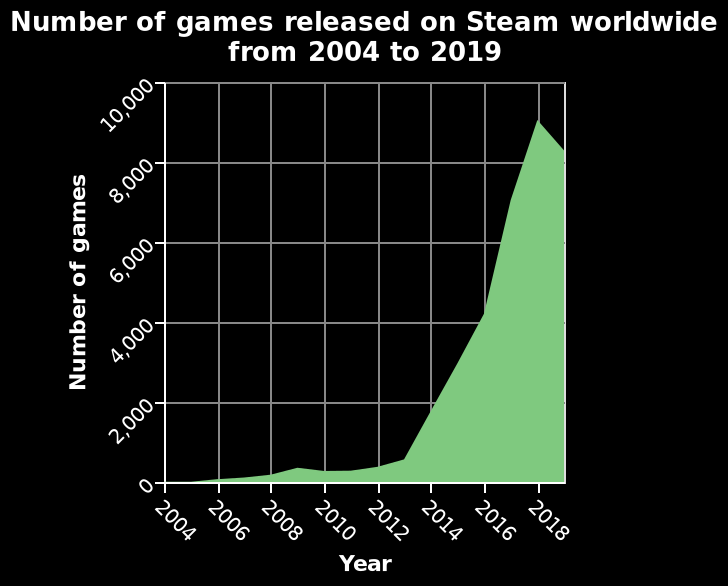<image>
What trend can be observed in the number of games released on Steam worldwide between 2004-2018?  The number of games released on Steam worldwide increases between the years 2004-2018. 